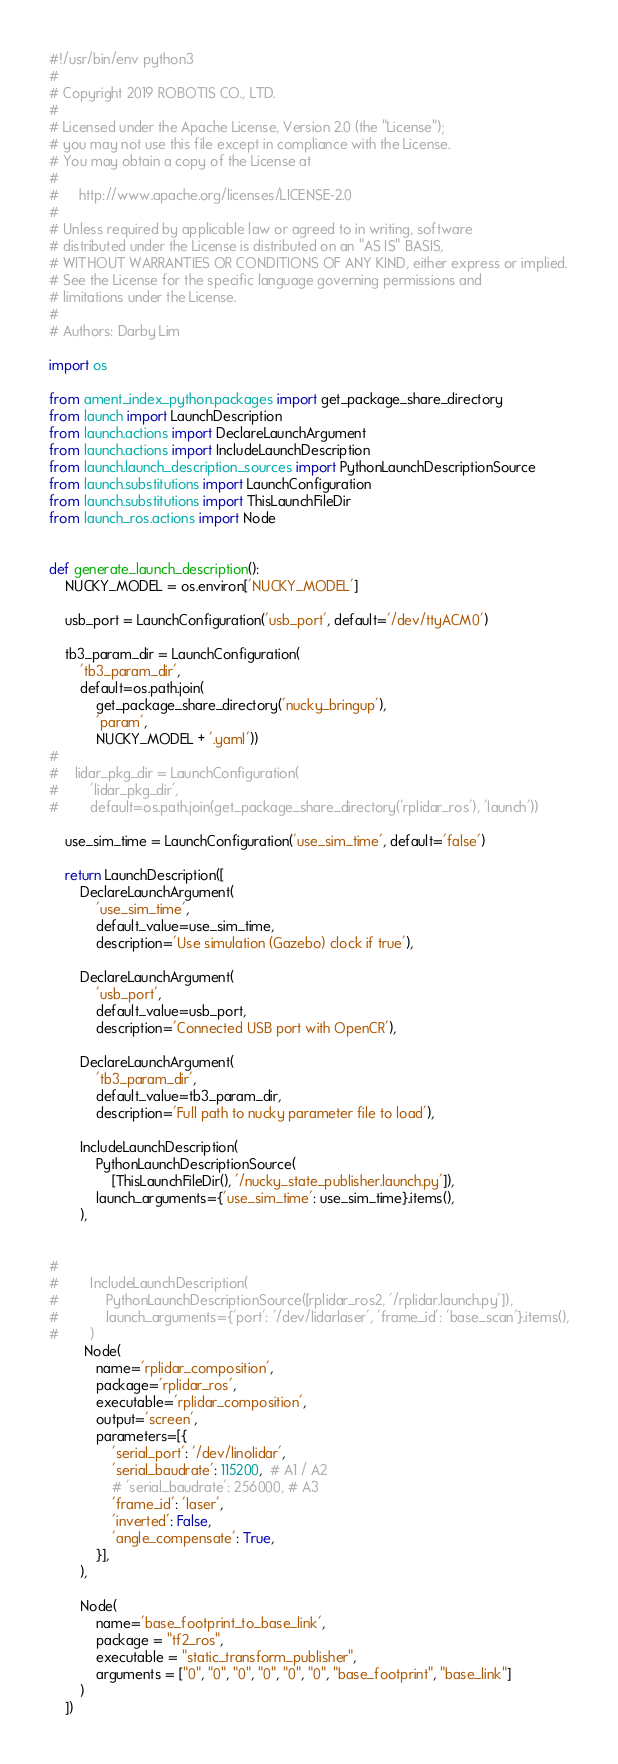<code> <loc_0><loc_0><loc_500><loc_500><_Python_>#!/usr/bin/env python3
#
# Copyright 2019 ROBOTIS CO., LTD.
#
# Licensed under the Apache License, Version 2.0 (the "License");
# you may not use this file except in compliance with the License.
# You may obtain a copy of the License at
#
#     http://www.apache.org/licenses/LICENSE-2.0
#
# Unless required by applicable law or agreed to in writing, software
# distributed under the License is distributed on an "AS IS" BASIS,
# WITHOUT WARRANTIES OR CONDITIONS OF ANY KIND, either express or implied.
# See the License for the specific language governing permissions and
# limitations under the License.
#
# Authors: Darby Lim

import os

from ament_index_python.packages import get_package_share_directory
from launch import LaunchDescription
from launch.actions import DeclareLaunchArgument
from launch.actions import IncludeLaunchDescription
from launch.launch_description_sources import PythonLaunchDescriptionSource
from launch.substitutions import LaunchConfiguration
from launch.substitutions import ThisLaunchFileDir
from launch_ros.actions import Node


def generate_launch_description():
    NUCKY_MODEL = os.environ['NUCKY_MODEL']

    usb_port = LaunchConfiguration('usb_port', default='/dev/ttyACM0')

    tb3_param_dir = LaunchConfiguration(
        'tb3_param_dir',
        default=os.path.join(
            get_package_share_directory('nucky_bringup'),
            'param',
            NUCKY_MODEL + '.yaml'))
#
#    lidar_pkg_dir = LaunchConfiguration(
#        'lidar_pkg_dir',
#        default=os.path.join(get_package_share_directory('rplidar_ros'), 'launch'))

    use_sim_time = LaunchConfiguration('use_sim_time', default='false')

    return LaunchDescription([
        DeclareLaunchArgument(
            'use_sim_time',
            default_value=use_sim_time,
            description='Use simulation (Gazebo) clock if true'),

        DeclareLaunchArgument(
            'usb_port',
            default_value=usb_port,
            description='Connected USB port with OpenCR'),

        DeclareLaunchArgument(
            'tb3_param_dir',
            default_value=tb3_param_dir,
            description='Full path to nucky parameter file to load'),

        IncludeLaunchDescription(
            PythonLaunchDescriptionSource(
                [ThisLaunchFileDir(), '/nucky_state_publisher.launch.py']),
            launch_arguments={'use_sim_time': use_sim_time}.items(),
        ),
        
 
#
#        IncludeLaunchDescription(
#            PythonLaunchDescriptionSource([rplidar_ros2, '/rplidar.launch.py']),
#            launch_arguments={'port': '/dev/lidarlaser', 'frame_id': 'base_scan'}.items(),
#        )
         Node(
            name='rplidar_composition',
            package='rplidar_ros',
            executable='rplidar_composition',
            output='screen',
            parameters=[{
                'serial_port': '/dev/linolidar',
                'serial_baudrate': 115200,  # A1 / A2
                # 'serial_baudrate': 256000, # A3
                'frame_id': 'laser',
                'inverted': False,
                'angle_compensate': True,
            }],
        ),

        Node(
            name='base_footprint_to_base_link',
            package = "tf2_ros", 
            executable = "static_transform_publisher",
            arguments = ["0", "0", "0", "0", "0", "0", "base_footprint", "base_link"]
        )
    ])
</code> 